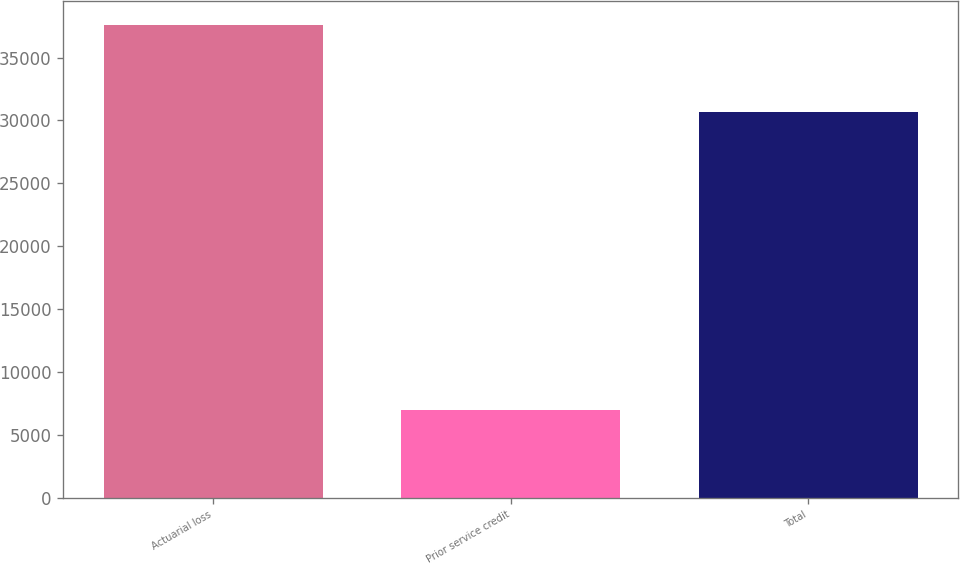Convert chart to OTSL. <chart><loc_0><loc_0><loc_500><loc_500><bar_chart><fcel>Actuarial loss<fcel>Prior service credit<fcel>Total<nl><fcel>37616<fcel>6951<fcel>30665<nl></chart> 